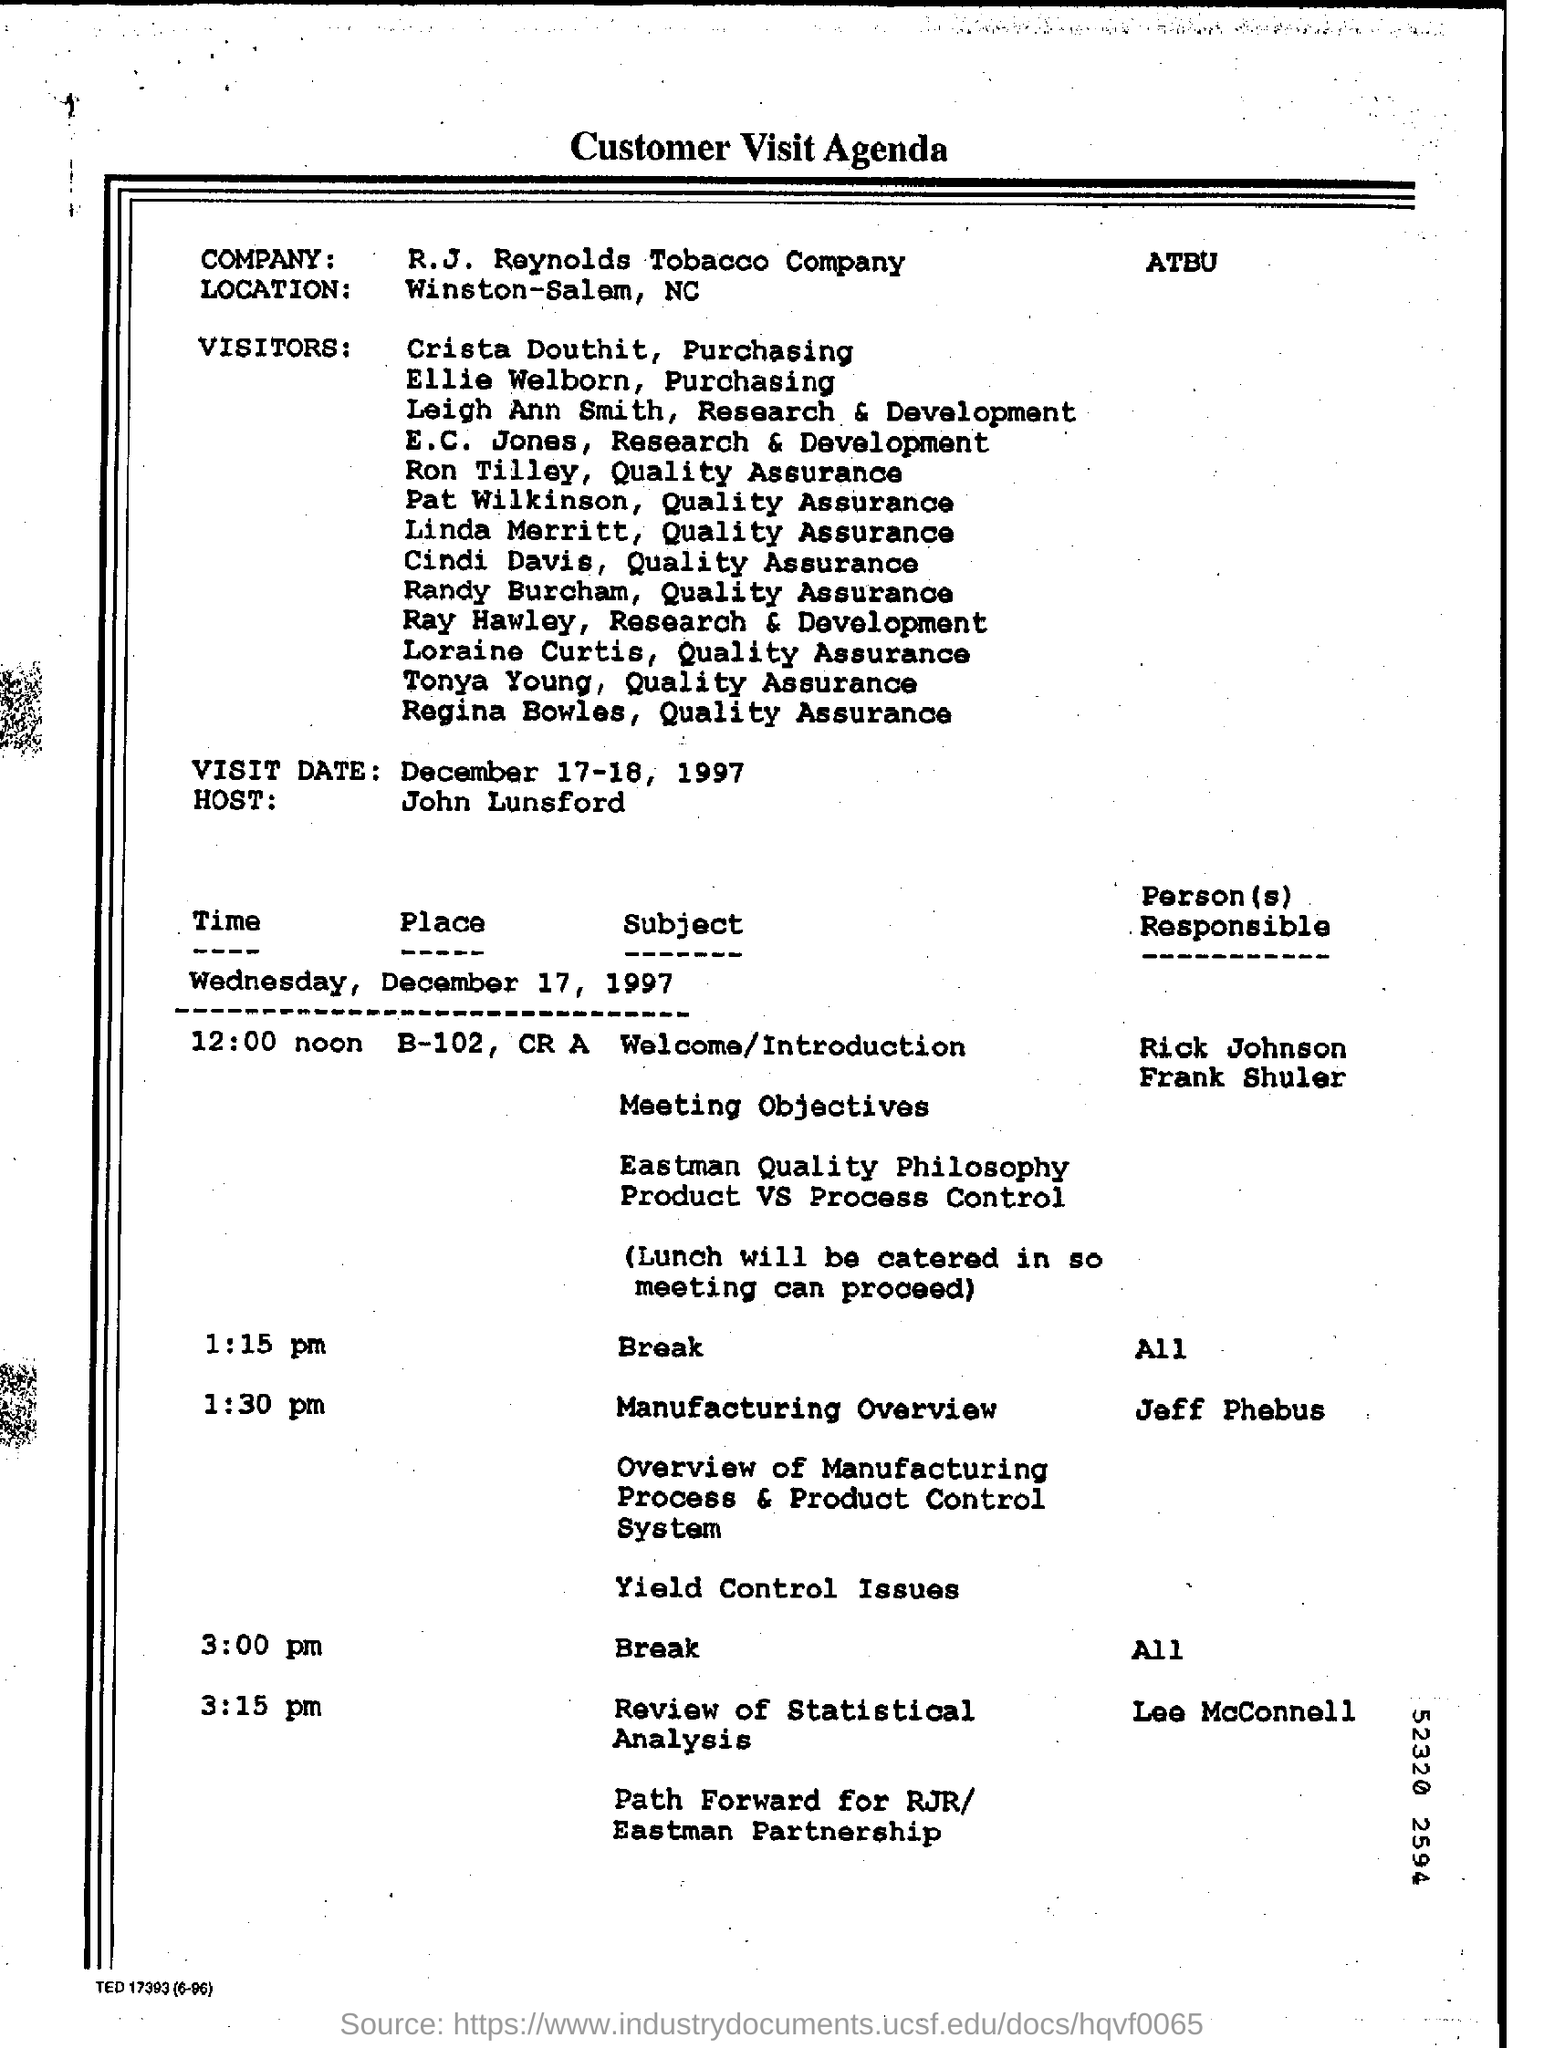Point out several critical features in this image. John Lunsford is hosting the customer visit. It is expected that the first break will commence at 1:15 pm. It is Jeff Phebus who is presenting the manufacturing overview. The company is situated in Winston-Salem, North Carolina. The second break is scheduled to occur at 3:00 pm. 